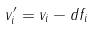Convert formula to latex. <formula><loc_0><loc_0><loc_500><loc_500>v ^ { \prime } _ { i } = v _ { i } - d f _ { i }</formula> 